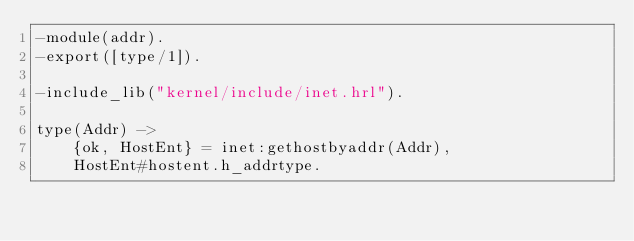Convert code to text. <code><loc_0><loc_0><loc_500><loc_500><_Erlang_>-module(addr).
-export([type/1]).

-include_lib("kernel/include/inet.hrl").

type(Addr) ->
    {ok, HostEnt} = inet:gethostbyaddr(Addr),
    HostEnt#hostent.h_addrtype.
</code> 